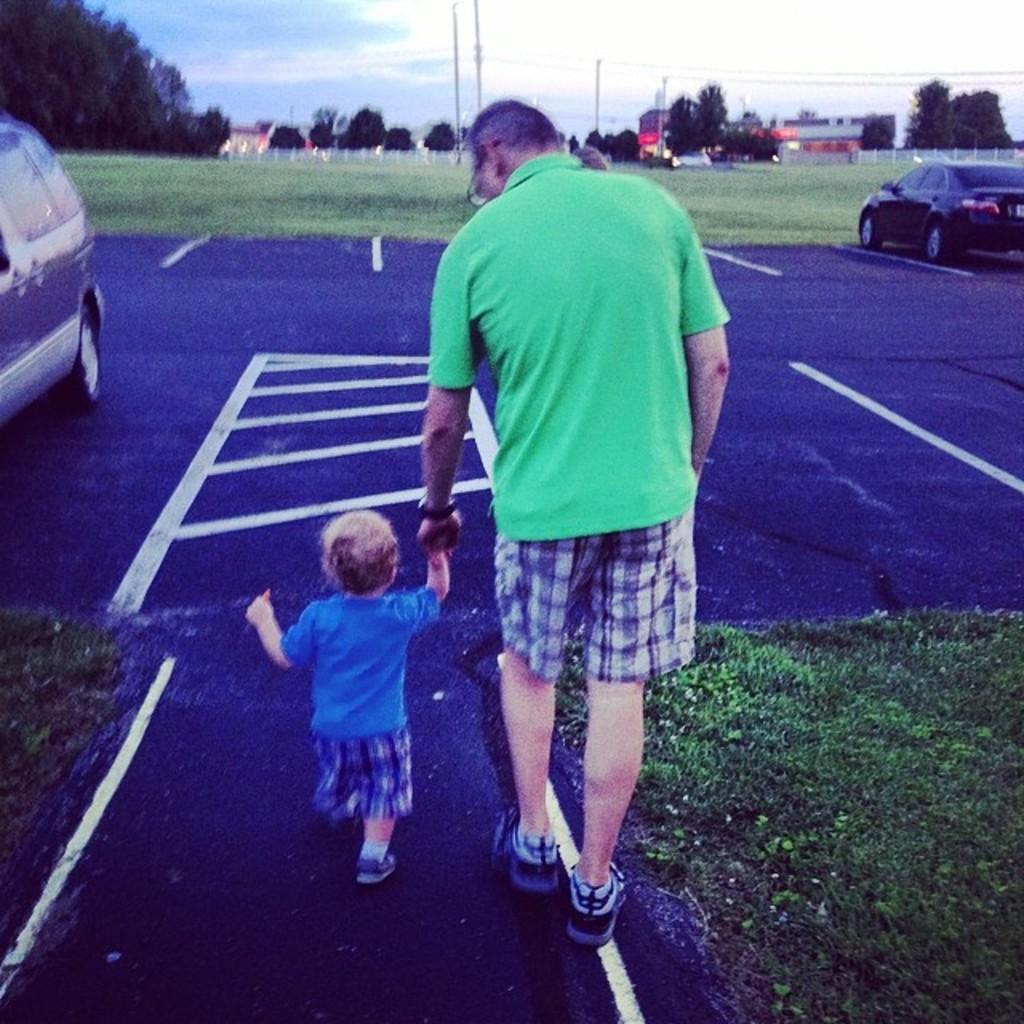Describe this image in one or two sentences. In this picture there is a man and kid walking on the road and we can see cars and grass. In the background of the image we can see trees, poles, fences and sky. 